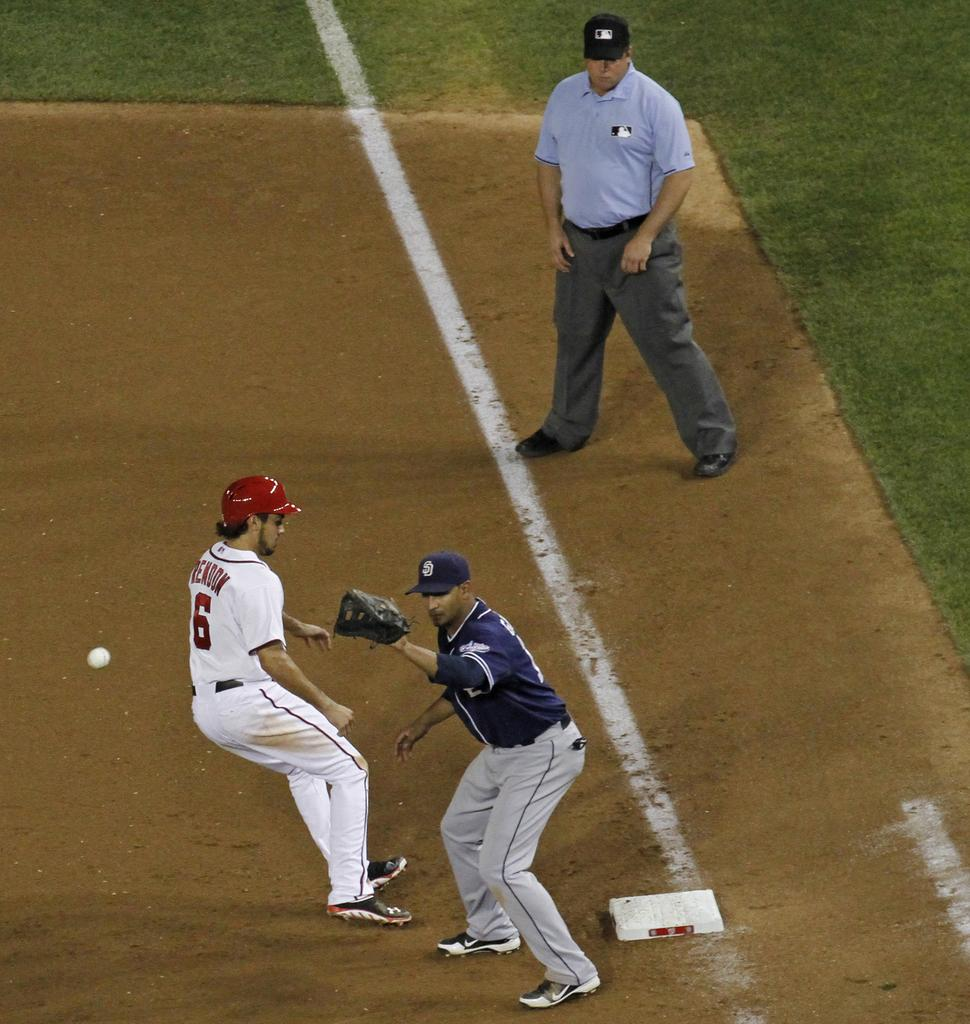<image>
Render a clear and concise summary of the photo. Player number 6 attempts to reach the base while playing a game of baseball. 